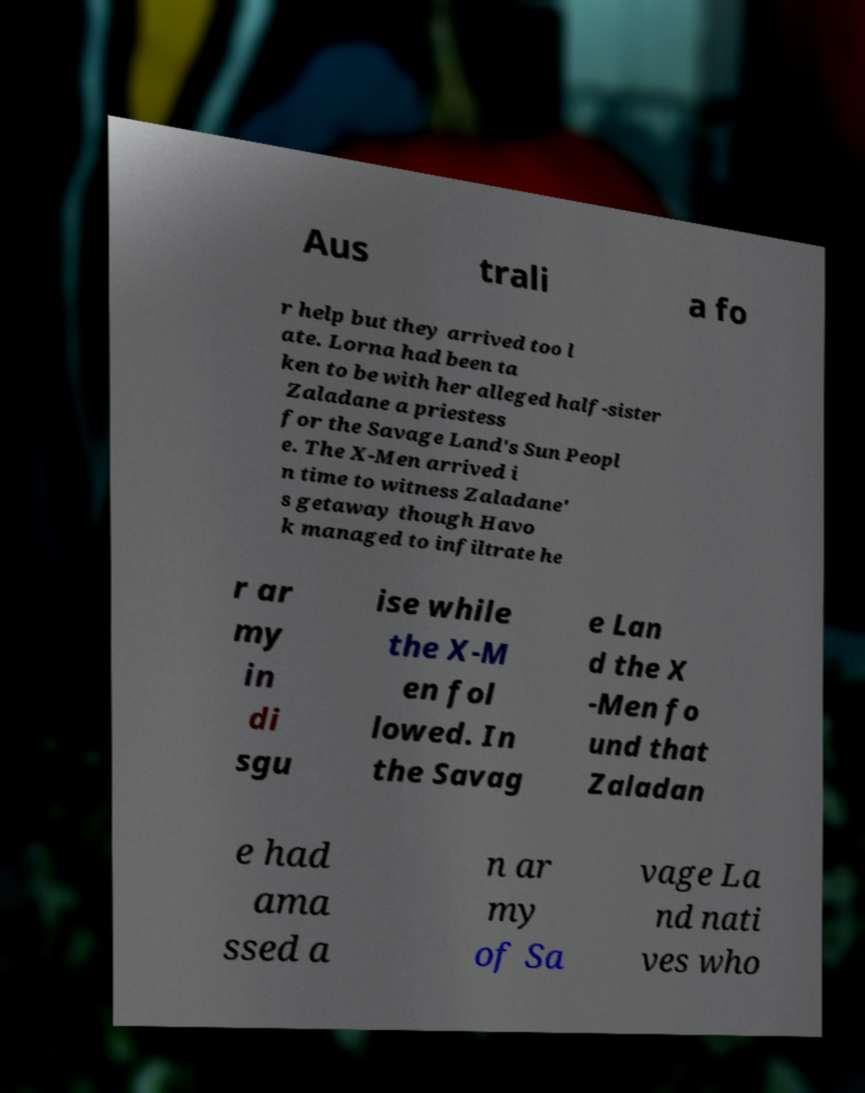What messages or text are displayed in this image? I need them in a readable, typed format. Aus trali a fo r help but they arrived too l ate. Lorna had been ta ken to be with her alleged half-sister Zaladane a priestess for the Savage Land's Sun Peopl e. The X-Men arrived i n time to witness Zaladane' s getaway though Havo k managed to infiltrate he r ar my in di sgu ise while the X-M en fol lowed. In the Savag e Lan d the X -Men fo und that Zaladan e had ama ssed a n ar my of Sa vage La nd nati ves who 